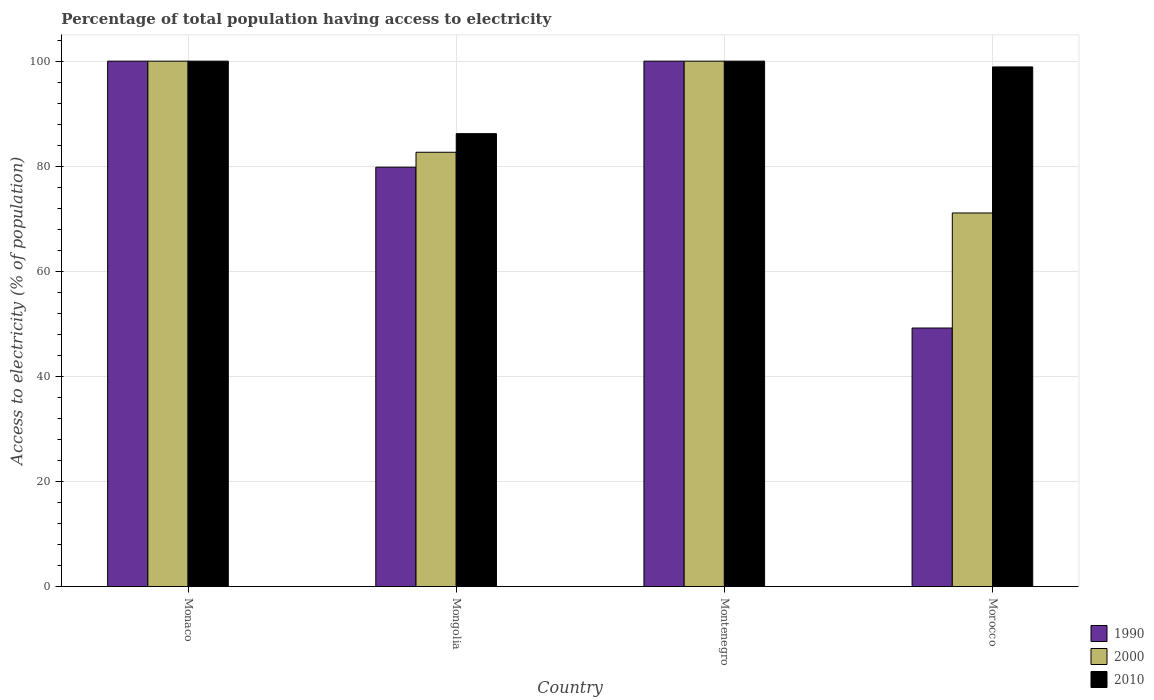How many different coloured bars are there?
Offer a terse response. 3. How many bars are there on the 3rd tick from the left?
Give a very brief answer. 3. What is the label of the 1st group of bars from the left?
Your answer should be compact. Monaco. What is the percentage of population that have access to electricity in 2000 in Morocco?
Keep it short and to the point. 71.1. Across all countries, what is the minimum percentage of population that have access to electricity in 1990?
Your response must be concise. 49.2. In which country was the percentage of population that have access to electricity in 1990 maximum?
Your answer should be very brief. Monaco. In which country was the percentage of population that have access to electricity in 2000 minimum?
Ensure brevity in your answer.  Morocco. What is the total percentage of population that have access to electricity in 1990 in the graph?
Your response must be concise. 329.02. What is the difference between the percentage of population that have access to electricity in 2000 in Monaco and that in Mongolia?
Give a very brief answer. 17.34. What is the difference between the percentage of population that have access to electricity in 1990 in Monaco and the percentage of population that have access to electricity in 2000 in Mongolia?
Your answer should be very brief. 17.34. What is the average percentage of population that have access to electricity in 2010 per country?
Offer a terse response. 96.28. What is the difference between the percentage of population that have access to electricity of/in 2010 and percentage of population that have access to electricity of/in 2000 in Morocco?
Your answer should be very brief. 27.8. In how many countries, is the percentage of population that have access to electricity in 2010 greater than 24 %?
Your answer should be very brief. 4. What is the ratio of the percentage of population that have access to electricity in 2000 in Montenegro to that in Morocco?
Keep it short and to the point. 1.41. Is the percentage of population that have access to electricity in 2010 in Monaco less than that in Morocco?
Your answer should be very brief. No. What is the difference between the highest and the second highest percentage of population that have access to electricity in 2010?
Provide a succinct answer. -1.1. What is the difference between the highest and the lowest percentage of population that have access to electricity in 1990?
Provide a short and direct response. 50.8. In how many countries, is the percentage of population that have access to electricity in 2000 greater than the average percentage of population that have access to electricity in 2000 taken over all countries?
Your answer should be very brief. 2. What does the 3rd bar from the left in Morocco represents?
Offer a very short reply. 2010. What does the 1st bar from the right in Monaco represents?
Ensure brevity in your answer.  2010. How many bars are there?
Provide a short and direct response. 12. How many countries are there in the graph?
Your answer should be very brief. 4. What is the difference between two consecutive major ticks on the Y-axis?
Give a very brief answer. 20. Does the graph contain grids?
Provide a succinct answer. Yes. Where does the legend appear in the graph?
Make the answer very short. Bottom right. What is the title of the graph?
Offer a very short reply. Percentage of total population having access to electricity. Does "1984" appear as one of the legend labels in the graph?
Provide a short and direct response. No. What is the label or title of the Y-axis?
Provide a short and direct response. Access to electricity (% of population). What is the Access to electricity (% of population) of 1990 in Mongolia?
Give a very brief answer. 79.82. What is the Access to electricity (% of population) of 2000 in Mongolia?
Your answer should be compact. 82.66. What is the Access to electricity (% of population) of 2010 in Mongolia?
Ensure brevity in your answer.  86.2. What is the Access to electricity (% of population) of 2010 in Montenegro?
Your response must be concise. 100. What is the Access to electricity (% of population) of 1990 in Morocco?
Your answer should be very brief. 49.2. What is the Access to electricity (% of population) in 2000 in Morocco?
Give a very brief answer. 71.1. What is the Access to electricity (% of population) of 2010 in Morocco?
Provide a short and direct response. 98.9. Across all countries, what is the minimum Access to electricity (% of population) of 1990?
Keep it short and to the point. 49.2. Across all countries, what is the minimum Access to electricity (% of population) in 2000?
Make the answer very short. 71.1. Across all countries, what is the minimum Access to electricity (% of population) in 2010?
Your response must be concise. 86.2. What is the total Access to electricity (% of population) in 1990 in the graph?
Your response must be concise. 329.02. What is the total Access to electricity (% of population) in 2000 in the graph?
Provide a succinct answer. 353.76. What is the total Access to electricity (% of population) in 2010 in the graph?
Provide a succinct answer. 385.1. What is the difference between the Access to electricity (% of population) of 1990 in Monaco and that in Mongolia?
Make the answer very short. 20.18. What is the difference between the Access to electricity (% of population) in 2000 in Monaco and that in Mongolia?
Keep it short and to the point. 17.34. What is the difference between the Access to electricity (% of population) of 2000 in Monaco and that in Montenegro?
Offer a very short reply. 0. What is the difference between the Access to electricity (% of population) in 2010 in Monaco and that in Montenegro?
Provide a succinct answer. 0. What is the difference between the Access to electricity (% of population) of 1990 in Monaco and that in Morocco?
Offer a very short reply. 50.8. What is the difference between the Access to electricity (% of population) in 2000 in Monaco and that in Morocco?
Your answer should be very brief. 28.9. What is the difference between the Access to electricity (% of population) in 2010 in Monaco and that in Morocco?
Ensure brevity in your answer.  1.1. What is the difference between the Access to electricity (% of population) in 1990 in Mongolia and that in Montenegro?
Your response must be concise. -20.18. What is the difference between the Access to electricity (% of population) in 2000 in Mongolia and that in Montenegro?
Provide a short and direct response. -17.34. What is the difference between the Access to electricity (% of population) in 2010 in Mongolia and that in Montenegro?
Ensure brevity in your answer.  -13.8. What is the difference between the Access to electricity (% of population) of 1990 in Mongolia and that in Morocco?
Ensure brevity in your answer.  30.62. What is the difference between the Access to electricity (% of population) in 2000 in Mongolia and that in Morocco?
Ensure brevity in your answer.  11.56. What is the difference between the Access to electricity (% of population) of 1990 in Montenegro and that in Morocco?
Make the answer very short. 50.8. What is the difference between the Access to electricity (% of population) in 2000 in Montenegro and that in Morocco?
Keep it short and to the point. 28.9. What is the difference between the Access to electricity (% of population) of 1990 in Monaco and the Access to electricity (% of population) of 2000 in Mongolia?
Make the answer very short. 17.34. What is the difference between the Access to electricity (% of population) in 1990 in Monaco and the Access to electricity (% of population) in 2010 in Mongolia?
Your answer should be compact. 13.8. What is the difference between the Access to electricity (% of population) in 2000 in Monaco and the Access to electricity (% of population) in 2010 in Mongolia?
Provide a succinct answer. 13.8. What is the difference between the Access to electricity (% of population) of 1990 in Monaco and the Access to electricity (% of population) of 2000 in Morocco?
Your answer should be compact. 28.9. What is the difference between the Access to electricity (% of population) of 2000 in Monaco and the Access to electricity (% of population) of 2010 in Morocco?
Your response must be concise. 1.1. What is the difference between the Access to electricity (% of population) of 1990 in Mongolia and the Access to electricity (% of population) of 2000 in Montenegro?
Offer a terse response. -20.18. What is the difference between the Access to electricity (% of population) of 1990 in Mongolia and the Access to electricity (% of population) of 2010 in Montenegro?
Your response must be concise. -20.18. What is the difference between the Access to electricity (% of population) in 2000 in Mongolia and the Access to electricity (% of population) in 2010 in Montenegro?
Your response must be concise. -17.34. What is the difference between the Access to electricity (% of population) of 1990 in Mongolia and the Access to electricity (% of population) of 2000 in Morocco?
Ensure brevity in your answer.  8.72. What is the difference between the Access to electricity (% of population) of 1990 in Mongolia and the Access to electricity (% of population) of 2010 in Morocco?
Your answer should be compact. -19.08. What is the difference between the Access to electricity (% of population) in 2000 in Mongolia and the Access to electricity (% of population) in 2010 in Morocco?
Your response must be concise. -16.24. What is the difference between the Access to electricity (% of population) of 1990 in Montenegro and the Access to electricity (% of population) of 2000 in Morocco?
Keep it short and to the point. 28.9. What is the difference between the Access to electricity (% of population) of 1990 in Montenegro and the Access to electricity (% of population) of 2010 in Morocco?
Provide a short and direct response. 1.1. What is the average Access to electricity (% of population) of 1990 per country?
Your answer should be compact. 82.25. What is the average Access to electricity (% of population) in 2000 per country?
Provide a short and direct response. 88.44. What is the average Access to electricity (% of population) in 2010 per country?
Your answer should be compact. 96.28. What is the difference between the Access to electricity (% of population) of 1990 and Access to electricity (% of population) of 2000 in Monaco?
Your response must be concise. 0. What is the difference between the Access to electricity (% of population) of 1990 and Access to electricity (% of population) of 2010 in Monaco?
Provide a succinct answer. 0. What is the difference between the Access to electricity (% of population) of 1990 and Access to electricity (% of population) of 2000 in Mongolia?
Offer a very short reply. -2.84. What is the difference between the Access to electricity (% of population) in 1990 and Access to electricity (% of population) in 2010 in Mongolia?
Provide a short and direct response. -6.38. What is the difference between the Access to electricity (% of population) in 2000 and Access to electricity (% of population) in 2010 in Mongolia?
Your answer should be compact. -3.54. What is the difference between the Access to electricity (% of population) in 1990 and Access to electricity (% of population) in 2000 in Montenegro?
Make the answer very short. 0. What is the difference between the Access to electricity (% of population) in 1990 and Access to electricity (% of population) in 2000 in Morocco?
Ensure brevity in your answer.  -21.9. What is the difference between the Access to electricity (% of population) of 1990 and Access to electricity (% of population) of 2010 in Morocco?
Make the answer very short. -49.7. What is the difference between the Access to electricity (% of population) in 2000 and Access to electricity (% of population) in 2010 in Morocco?
Your response must be concise. -27.8. What is the ratio of the Access to electricity (% of population) in 1990 in Monaco to that in Mongolia?
Offer a very short reply. 1.25. What is the ratio of the Access to electricity (% of population) of 2000 in Monaco to that in Mongolia?
Your answer should be very brief. 1.21. What is the ratio of the Access to electricity (% of population) of 2010 in Monaco to that in Mongolia?
Give a very brief answer. 1.16. What is the ratio of the Access to electricity (% of population) in 1990 in Monaco to that in Morocco?
Your answer should be very brief. 2.03. What is the ratio of the Access to electricity (% of population) in 2000 in Monaco to that in Morocco?
Your response must be concise. 1.41. What is the ratio of the Access to electricity (% of population) in 2010 in Monaco to that in Morocco?
Make the answer very short. 1.01. What is the ratio of the Access to electricity (% of population) in 1990 in Mongolia to that in Montenegro?
Your answer should be very brief. 0.8. What is the ratio of the Access to electricity (% of population) of 2000 in Mongolia to that in Montenegro?
Keep it short and to the point. 0.83. What is the ratio of the Access to electricity (% of population) of 2010 in Mongolia to that in Montenegro?
Your response must be concise. 0.86. What is the ratio of the Access to electricity (% of population) of 1990 in Mongolia to that in Morocco?
Make the answer very short. 1.62. What is the ratio of the Access to electricity (% of population) in 2000 in Mongolia to that in Morocco?
Your answer should be compact. 1.16. What is the ratio of the Access to electricity (% of population) of 2010 in Mongolia to that in Morocco?
Keep it short and to the point. 0.87. What is the ratio of the Access to electricity (% of population) in 1990 in Montenegro to that in Morocco?
Provide a succinct answer. 2.03. What is the ratio of the Access to electricity (% of population) in 2000 in Montenegro to that in Morocco?
Your answer should be compact. 1.41. What is the ratio of the Access to electricity (% of population) in 2010 in Montenegro to that in Morocco?
Provide a short and direct response. 1.01. What is the difference between the highest and the second highest Access to electricity (% of population) in 2000?
Your response must be concise. 0. What is the difference between the highest and the lowest Access to electricity (% of population) of 1990?
Make the answer very short. 50.8. What is the difference between the highest and the lowest Access to electricity (% of population) in 2000?
Provide a succinct answer. 28.9. 